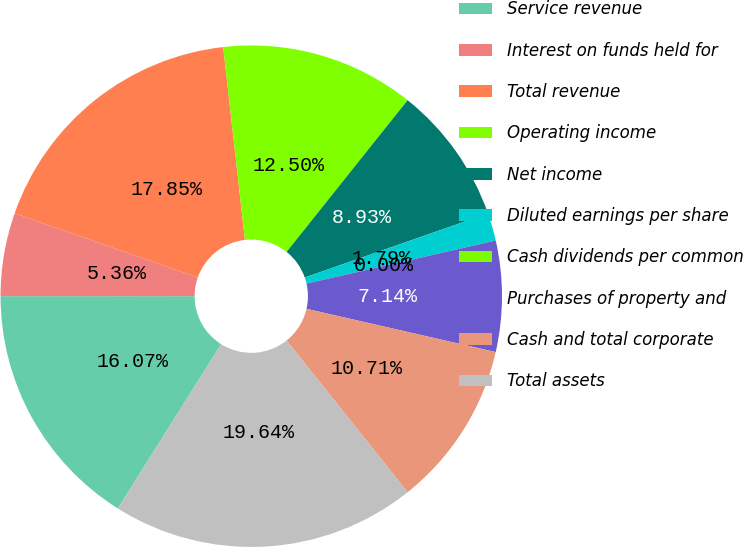Convert chart. <chart><loc_0><loc_0><loc_500><loc_500><pie_chart><fcel>Service revenue<fcel>Interest on funds held for<fcel>Total revenue<fcel>Operating income<fcel>Net income<fcel>Diluted earnings per share<fcel>Cash dividends per common<fcel>Purchases of property and<fcel>Cash and total corporate<fcel>Total assets<nl><fcel>16.07%<fcel>5.36%<fcel>17.85%<fcel>12.5%<fcel>8.93%<fcel>1.79%<fcel>0.0%<fcel>7.14%<fcel>10.71%<fcel>19.64%<nl></chart> 